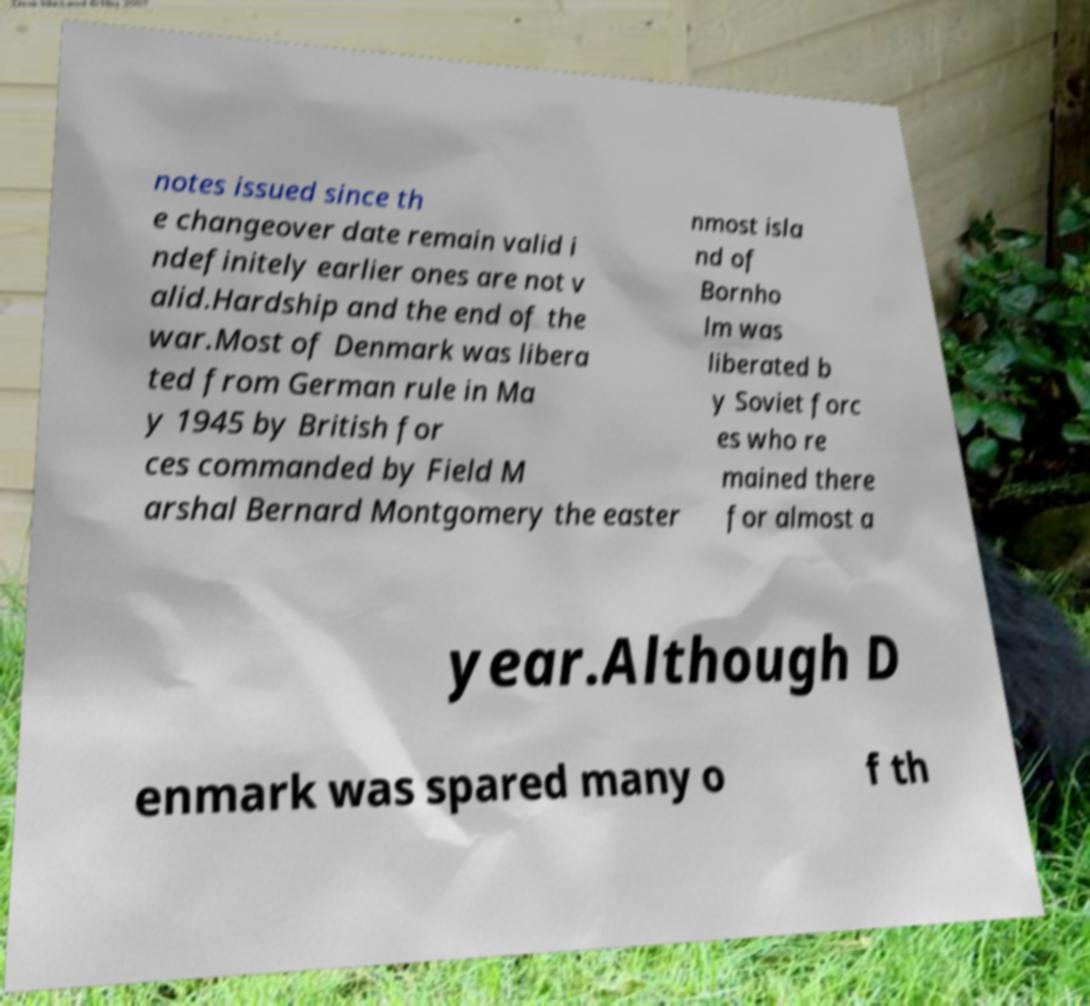Please identify and transcribe the text found in this image. notes issued since th e changeover date remain valid i ndefinitely earlier ones are not v alid.Hardship and the end of the war.Most of Denmark was libera ted from German rule in Ma y 1945 by British for ces commanded by Field M arshal Bernard Montgomery the easter nmost isla nd of Bornho lm was liberated b y Soviet forc es who re mained there for almost a year.Although D enmark was spared many o f th 